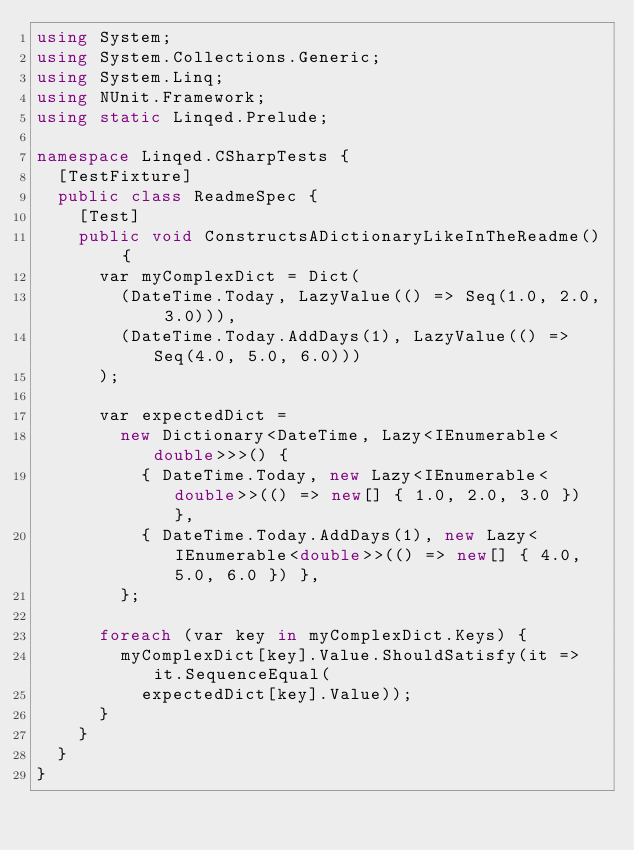Convert code to text. <code><loc_0><loc_0><loc_500><loc_500><_C#_>using System;
using System.Collections.Generic;
using System.Linq;
using NUnit.Framework;
using static Linqed.Prelude;

namespace Linqed.CSharpTests {
  [TestFixture]
  public class ReadmeSpec {
    [Test]
    public void ConstructsADictionaryLikeInTheReadme() { 
      var myComplexDict = Dict(
        (DateTime.Today, LazyValue(() => Seq(1.0, 2.0, 3.0))),
        (DateTime.Today.AddDays(1), LazyValue(() => Seq(4.0, 5.0, 6.0)))
      );

      var expectedDict = 
        new Dictionary<DateTime, Lazy<IEnumerable<double>>>() { 
          { DateTime.Today, new Lazy<IEnumerable<double>>(() => new[] { 1.0, 2.0, 3.0 }) },
          { DateTime.Today.AddDays(1), new Lazy<IEnumerable<double>>(() => new[] { 4.0, 5.0, 6.0 }) },
        };

      foreach (var key in myComplexDict.Keys) {
        myComplexDict[key].Value.ShouldSatisfy(it => it.SequenceEqual(
          expectedDict[key].Value));
      }
    }
  }
}
</code> 